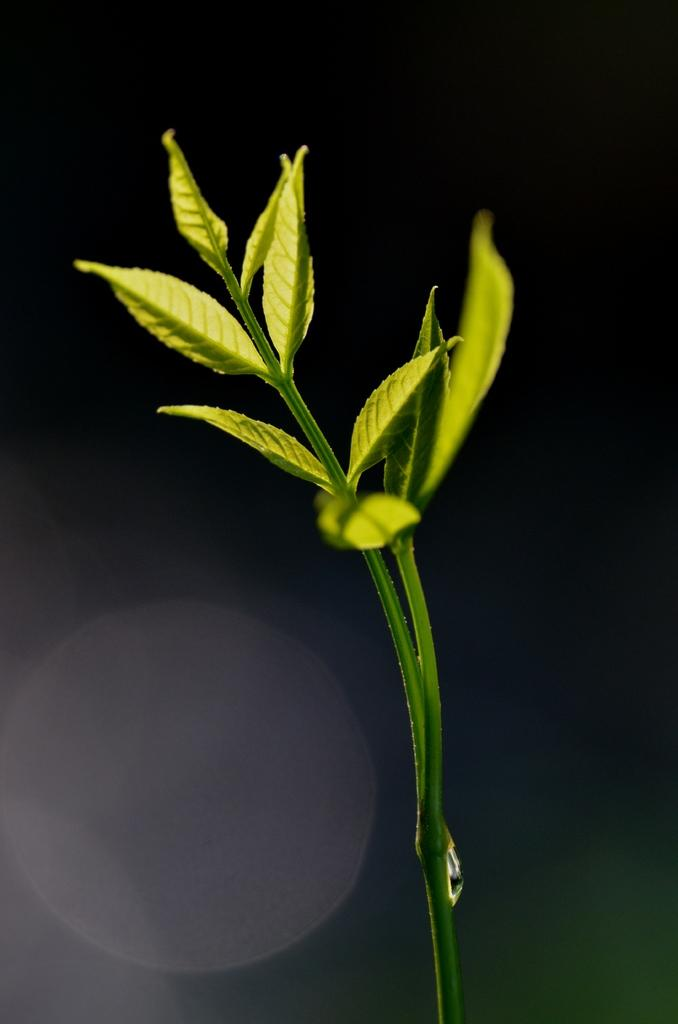What is the main subject of the image? The main subject of the image is a stem. What is attached to the stem? There are leaves attached to the stem. Is there any additional detail visible on the stem? Yes, there is a water droplet on the stem. What type of quince is growing on the stem in the image? There is no quince present in the image. --- Facts: 1. There is a car in the image. 2. The car is red. 3. The car has four wheels. 4. The car is parked on the street. 5. There are people walking on the sidewalk. Absurd Topics: unicorn, telescope Conversation: What is the main subject in the image? The main subject in the image is a car. Can you describe the car in the image? Yes, the car in the image is red and has four wheels. Where is the car located in the image? The car is parked on the street in the image. What else can be seen in the image? There are people walking on the sidewalk in the image. Reasoning: Let's think step by step in order to produce the conversation. We start by identifying the main subject of the image, which is the car. Next, we describe specific features of the car, such as its color and the number of wheels it has. Then, we observe the location of the car in the image, which is parked on the street. Finally, we describe any additional elements visible in the image, which in this case are the people walking on the sidewalk. Absurd Question/Answer: Can you see a unicorn in the image? No, there is no unicorn present in the image. --- Facts: 1. There is a group of people in the image. 2. The people are wearing hats. 3. The people are holding hands. 4. The people are standing in front of a building. 5. The building has a large sign on its facade. Absurd Topics: elephant, piano, concert Conversation: How many people are in the image? There is a group of people in the image. What are the people wearing in the image? The people are wearing hats in the image. What are the people doing in the image? The people are holding hands in the image. Where are the people located in the image? The people are standing in front of a building in the image. What can be seen on the building in the image? The building has a large sign on its facade in the image. Reasoning: Let's think step by step in order to produce the conversation. We start by identifying the main subject of the image, which is the group of people. Next, we describe specific features of the people, such as their clothing accessories, which in this case are the hats they are wearing. Then, we observe the actions of the people in the image, which 